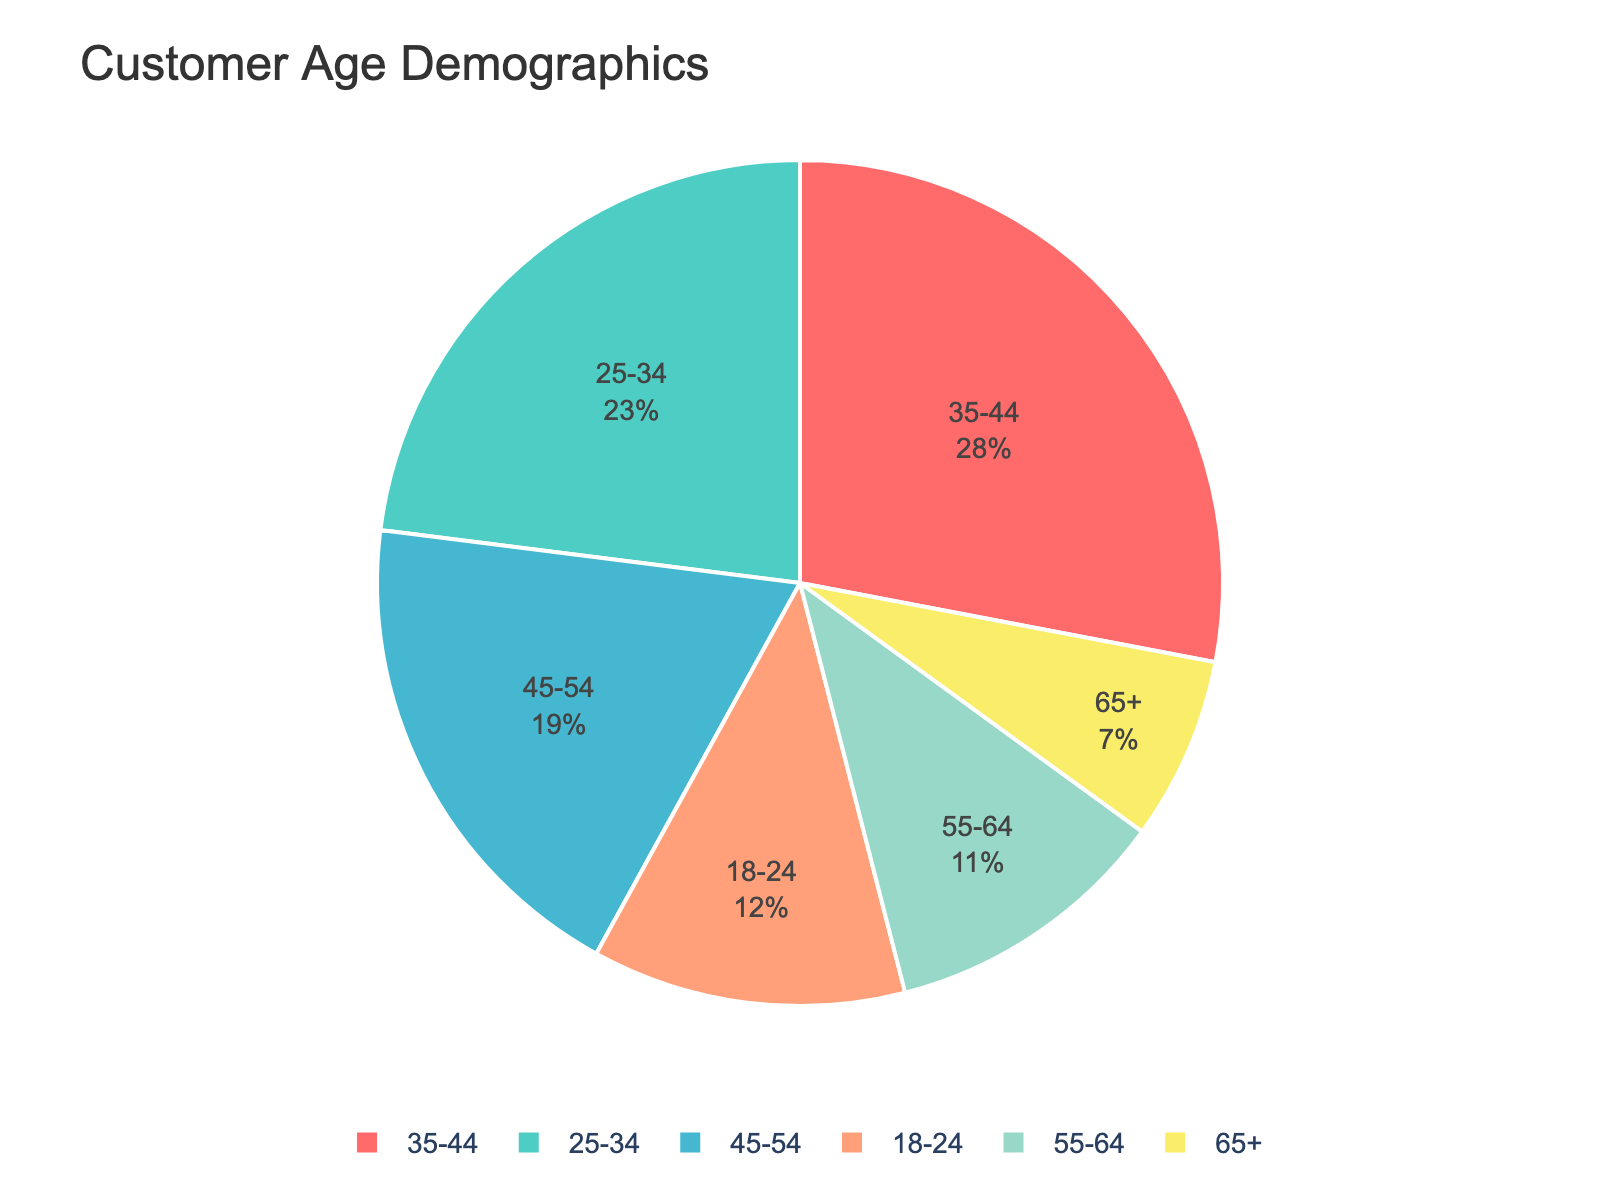What is the age group with the highest percentage of visitors? To find the age group with the highest percentage, look at the part of the pie chart with the largest area.
Answer: 35-44 What is the combined percentage of visitors aged 18-24 and 65+? Add the percentages of the 18-24 and 65+ age groups (12% and 7%) to find the total. 12 + 7 = 19
Answer: 19% How much larger is the percentage of visitors aged 25-34 compared to those aged 55-64? Subtract the percentage of the 55-64 age group from the 25-34 age group (23% - 11%). 23 - 11 = 12
Answer: 12% Which two age groups have the closest percentages of visitors? Compare the percentages to find the smallest difference. The 18-24 group has 12% and the 55-64 group has 11%; their difference is 1%.
Answer: 18-24 and 55-64 How does the percentage of visitors aged 45-54 compare to the percentage of visitors aged 18-24? Look at the chart and identify the percentages of the 45-54 and 18-24 age groups. 45-54 has 19%, and 18-24 has 12%. 19% is greater than 12%.
Answer: Greater Which segment is colored in green? Identify the color used for each segment in the pie chart. The green segment corresponds to the 25-34 age group.
Answer: 25-34 What is the sum of the percentages of visitors aged 35-44 and 45-54? Add the percentages of these two age groups (28% and 19%). 28 + 19 = 47
Answer: 47% What percentage of visitors are aged 55 and above? Add the percentages of the 55-64 and 65+ age groups (11% and 7%). 11 + 7 = 18
Answer: 18% Is the percentage of visitors aged 18-24 greater than, less than, or equal to the percentage of visitors aged 65+? Compare the percentages of the two age groups (12% for 18-24 and 7% for 65+). 12 is greater than 7.
Answer: Greater 